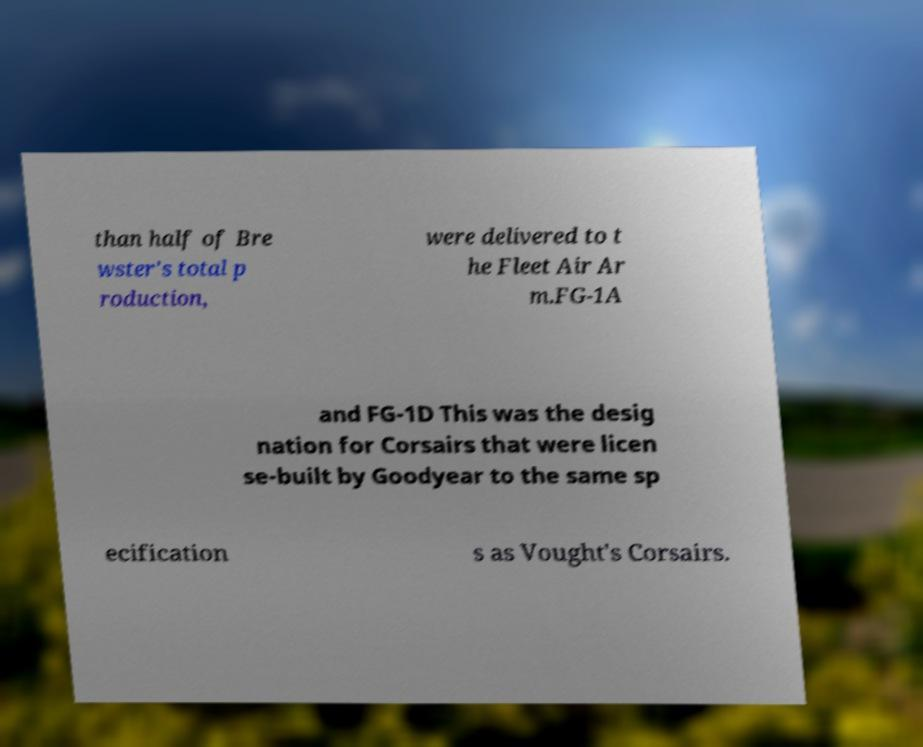Can you accurately transcribe the text from the provided image for me? than half of Bre wster's total p roduction, were delivered to t he Fleet Air Ar m.FG-1A and FG-1D This was the desig nation for Corsairs that were licen se-built by Goodyear to the same sp ecification s as Vought's Corsairs. 